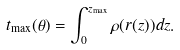Convert formula to latex. <formula><loc_0><loc_0><loc_500><loc_500>t _ { \max } ( \theta ) = \int _ { 0 } ^ { z _ { \max } } \rho ( r ( z ) ) d z .</formula> 